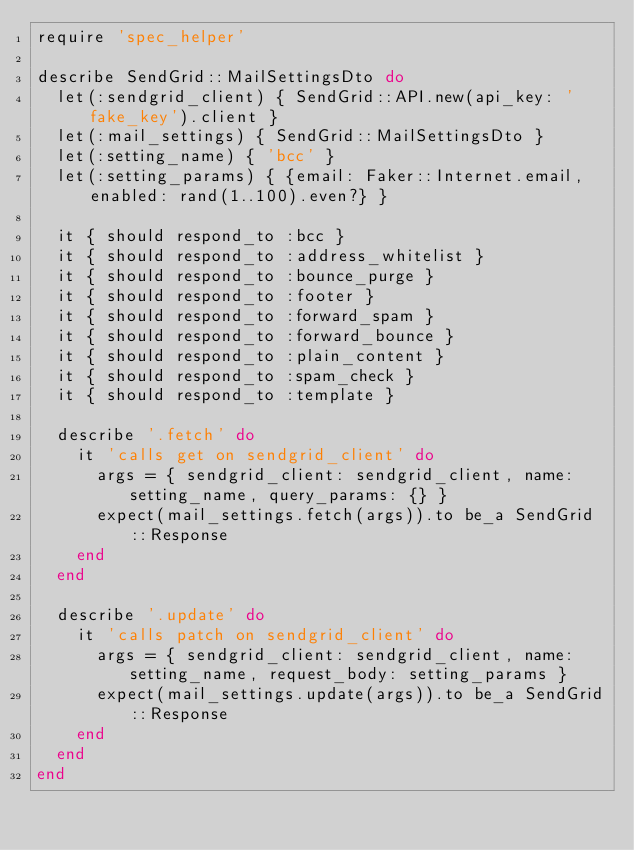Convert code to text. <code><loc_0><loc_0><loc_500><loc_500><_Ruby_>require 'spec_helper'

describe SendGrid::MailSettingsDto do
  let(:sendgrid_client) { SendGrid::API.new(api_key: 'fake_key').client }
  let(:mail_settings) { SendGrid::MailSettingsDto }
  let(:setting_name) { 'bcc' }
  let(:setting_params) { {email: Faker::Internet.email, enabled: rand(1..100).even?} }

  it { should respond_to :bcc }
  it { should respond_to :address_whitelist }
  it { should respond_to :bounce_purge }
  it { should respond_to :footer }
  it { should respond_to :forward_spam }
  it { should respond_to :forward_bounce }
  it { should respond_to :plain_content }
  it { should respond_to :spam_check }
  it { should respond_to :template }

  describe '.fetch' do
    it 'calls get on sendgrid_client' do
      args = { sendgrid_client: sendgrid_client, name: setting_name, query_params: {} }
      expect(mail_settings.fetch(args)).to be_a SendGrid::Response
    end
  end

  describe '.update' do
    it 'calls patch on sendgrid_client' do
      args = { sendgrid_client: sendgrid_client, name: setting_name, request_body: setting_params }
      expect(mail_settings.update(args)).to be_a SendGrid::Response
    end
  end
end
</code> 